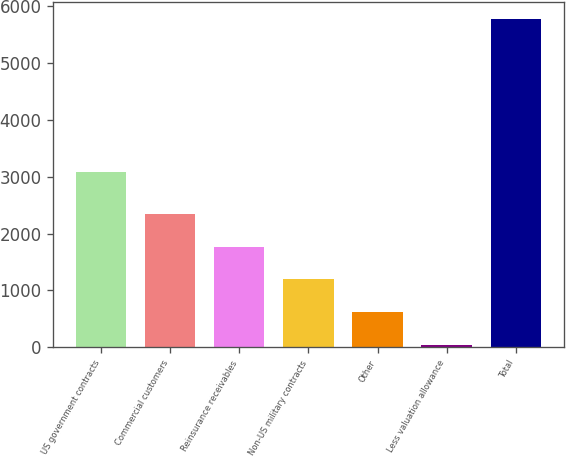<chart> <loc_0><loc_0><loc_500><loc_500><bar_chart><fcel>US government contracts<fcel>Commercial customers<fcel>Reinsurance receivables<fcel>Non-US military contracts<fcel>Other<fcel>Less valuation allowance<fcel>Total<nl><fcel>3090<fcel>2338.6<fcel>1764.2<fcel>1189.8<fcel>615.4<fcel>41<fcel>5785<nl></chart> 